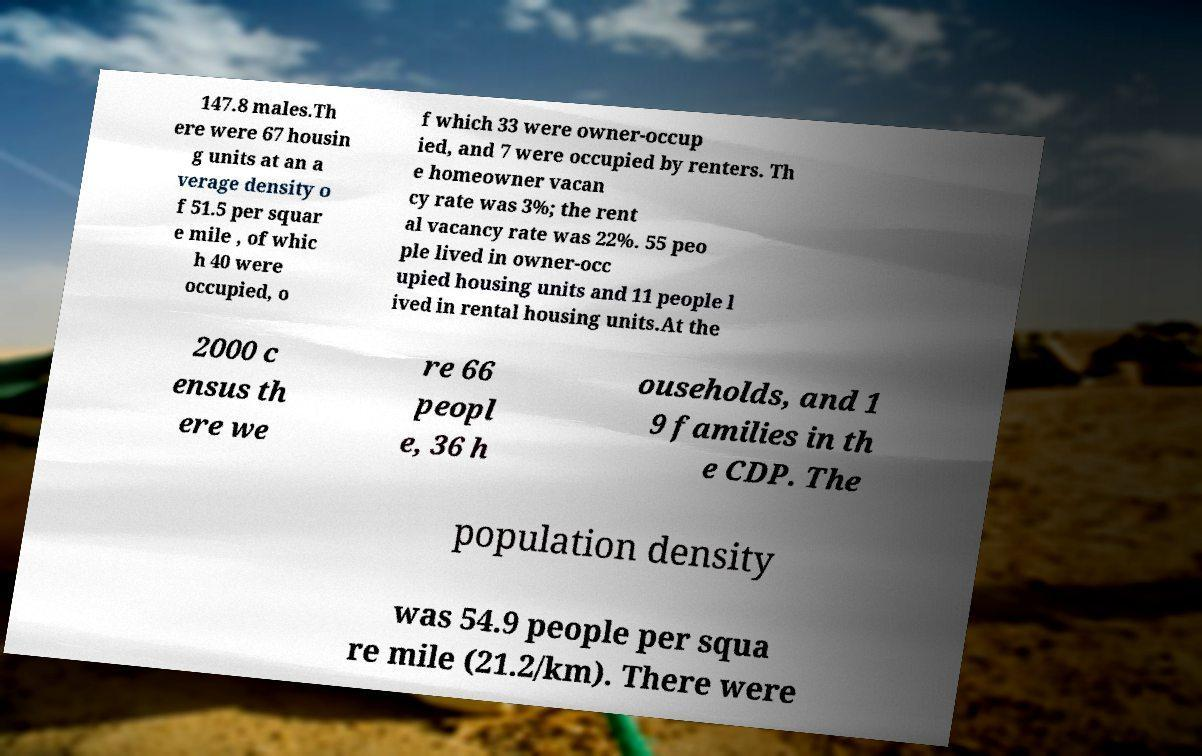Please identify and transcribe the text found in this image. 147.8 males.Th ere were 67 housin g units at an a verage density o f 51.5 per squar e mile , of whic h 40 were occupied, o f which 33 were owner-occup ied, and 7 were occupied by renters. Th e homeowner vacan cy rate was 3%; the rent al vacancy rate was 22%. 55 peo ple lived in owner-occ upied housing units and 11 people l ived in rental housing units.At the 2000 c ensus th ere we re 66 peopl e, 36 h ouseholds, and 1 9 families in th e CDP. The population density was 54.9 people per squa re mile (21.2/km). There were 